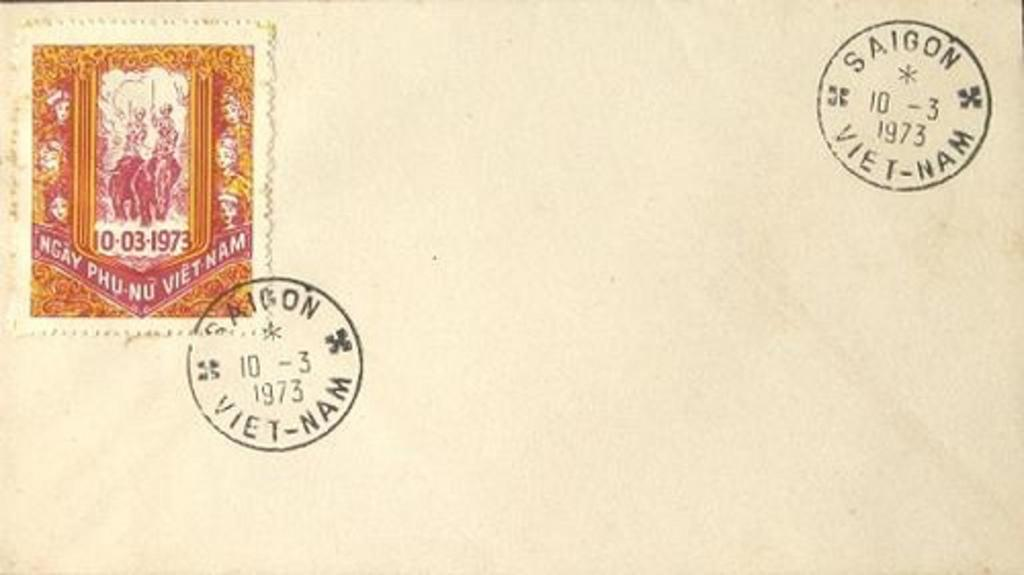Provide a one-sentence caption for the provided image. A letter has postmark stamps from Saigon, Vietnam from the year 1973. 